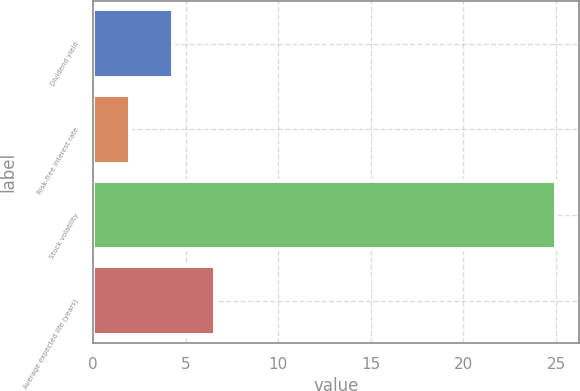<chart> <loc_0><loc_0><loc_500><loc_500><bar_chart><fcel>Dividend yield<fcel>Risk-free interest rate<fcel>Stock volatility<fcel>Average expected life (years)<nl><fcel>4.3<fcel>2<fcel>25<fcel>6.6<nl></chart> 